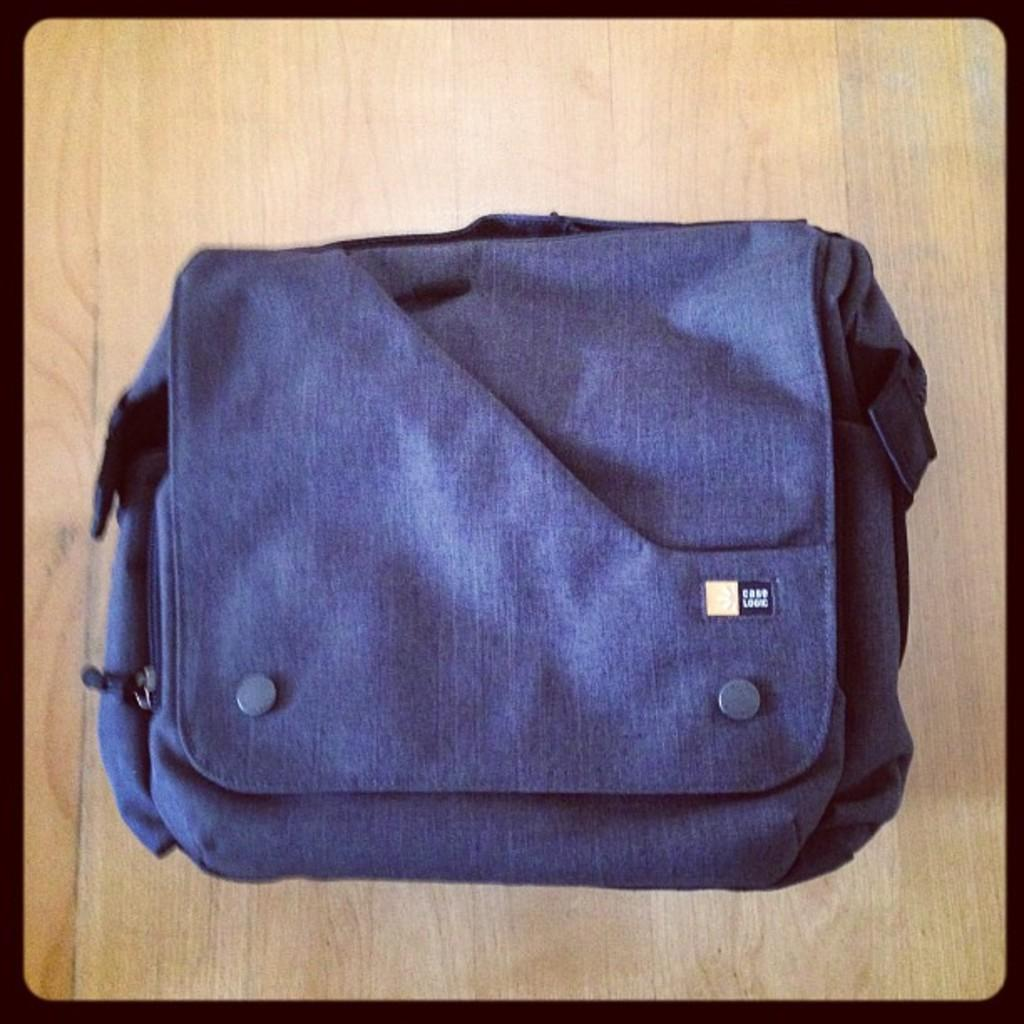What type of furniture is present in the image? There is a table in the image. What color is the table? The table is yellow. What object is placed on the table? There is a bag on the table. What color is the bag? The bag is blue. Can you see a bear crushing the gate in the image? No, there is no bear or gate present in the image. 